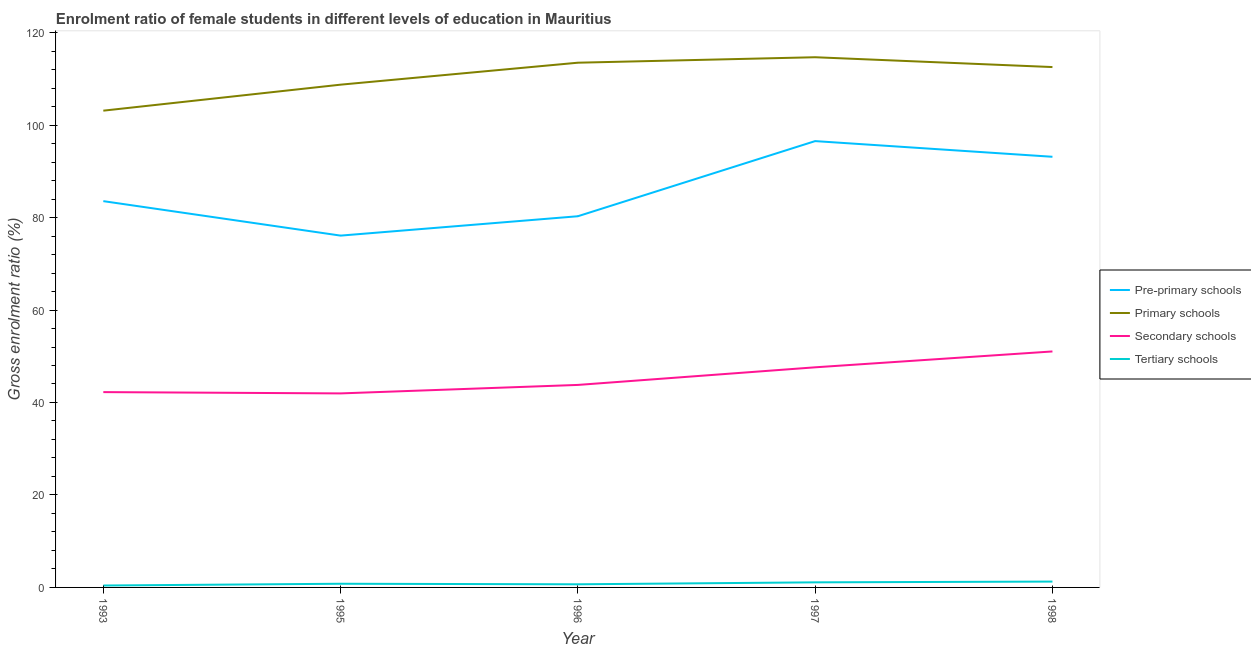How many different coloured lines are there?
Provide a short and direct response. 4. Does the line corresponding to gross enrolment ratio(male) in secondary schools intersect with the line corresponding to gross enrolment ratio(male) in pre-primary schools?
Your answer should be compact. No. Is the number of lines equal to the number of legend labels?
Provide a short and direct response. Yes. What is the gross enrolment ratio(male) in tertiary schools in 1998?
Your answer should be compact. 1.27. Across all years, what is the maximum gross enrolment ratio(male) in primary schools?
Keep it short and to the point. 114.68. Across all years, what is the minimum gross enrolment ratio(male) in pre-primary schools?
Make the answer very short. 76.1. In which year was the gross enrolment ratio(male) in primary schools minimum?
Provide a succinct answer. 1993. What is the total gross enrolment ratio(male) in secondary schools in the graph?
Your response must be concise. 226.66. What is the difference between the gross enrolment ratio(male) in primary schools in 1993 and that in 1995?
Give a very brief answer. -5.62. What is the difference between the gross enrolment ratio(male) in primary schools in 1998 and the gross enrolment ratio(male) in tertiary schools in 1996?
Offer a terse response. 111.87. What is the average gross enrolment ratio(male) in tertiary schools per year?
Keep it short and to the point. 0.85. In the year 1997, what is the difference between the gross enrolment ratio(male) in secondary schools and gross enrolment ratio(male) in primary schools?
Provide a short and direct response. -67.07. In how many years, is the gross enrolment ratio(male) in pre-primary schools greater than 72 %?
Keep it short and to the point. 5. What is the ratio of the gross enrolment ratio(male) in primary schools in 1997 to that in 1998?
Ensure brevity in your answer.  1.02. Is the difference between the gross enrolment ratio(male) in tertiary schools in 1996 and 1997 greater than the difference between the gross enrolment ratio(male) in pre-primary schools in 1996 and 1997?
Offer a terse response. Yes. What is the difference between the highest and the second highest gross enrolment ratio(male) in primary schools?
Keep it short and to the point. 1.18. What is the difference between the highest and the lowest gross enrolment ratio(male) in pre-primary schools?
Your answer should be compact. 20.44. In how many years, is the gross enrolment ratio(male) in primary schools greater than the average gross enrolment ratio(male) in primary schools taken over all years?
Your answer should be compact. 3. Is the sum of the gross enrolment ratio(male) in secondary schools in 1995 and 1996 greater than the maximum gross enrolment ratio(male) in tertiary schools across all years?
Your answer should be very brief. Yes. Is it the case that in every year, the sum of the gross enrolment ratio(male) in pre-primary schools and gross enrolment ratio(male) in primary schools is greater than the gross enrolment ratio(male) in secondary schools?
Your response must be concise. Yes. Does the gross enrolment ratio(male) in secondary schools monotonically increase over the years?
Your response must be concise. No. How many years are there in the graph?
Make the answer very short. 5. Does the graph contain any zero values?
Offer a terse response. No. Does the graph contain grids?
Give a very brief answer. No. Where does the legend appear in the graph?
Keep it short and to the point. Center right. How many legend labels are there?
Your answer should be very brief. 4. What is the title of the graph?
Your answer should be very brief. Enrolment ratio of female students in different levels of education in Mauritius. Does "Taxes on revenue" appear as one of the legend labels in the graph?
Give a very brief answer. No. What is the label or title of the Y-axis?
Keep it short and to the point. Gross enrolment ratio (%). What is the Gross enrolment ratio (%) in Pre-primary schools in 1993?
Your answer should be very brief. 83.55. What is the Gross enrolment ratio (%) in Primary schools in 1993?
Keep it short and to the point. 103.12. What is the Gross enrolment ratio (%) in Secondary schools in 1993?
Offer a terse response. 42.25. What is the Gross enrolment ratio (%) of Tertiary schools in 1993?
Provide a succinct answer. 0.41. What is the Gross enrolment ratio (%) of Pre-primary schools in 1995?
Your answer should be compact. 76.1. What is the Gross enrolment ratio (%) of Primary schools in 1995?
Keep it short and to the point. 108.74. What is the Gross enrolment ratio (%) of Secondary schools in 1995?
Your answer should be very brief. 41.97. What is the Gross enrolment ratio (%) of Tertiary schools in 1995?
Provide a short and direct response. 0.79. What is the Gross enrolment ratio (%) of Pre-primary schools in 1996?
Ensure brevity in your answer.  80.28. What is the Gross enrolment ratio (%) of Primary schools in 1996?
Your response must be concise. 113.49. What is the Gross enrolment ratio (%) of Secondary schools in 1996?
Offer a very short reply. 43.8. What is the Gross enrolment ratio (%) of Tertiary schools in 1996?
Make the answer very short. 0.68. What is the Gross enrolment ratio (%) in Pre-primary schools in 1997?
Offer a terse response. 96.54. What is the Gross enrolment ratio (%) of Primary schools in 1997?
Ensure brevity in your answer.  114.68. What is the Gross enrolment ratio (%) in Secondary schools in 1997?
Give a very brief answer. 47.61. What is the Gross enrolment ratio (%) of Tertiary schools in 1997?
Your response must be concise. 1.1. What is the Gross enrolment ratio (%) of Pre-primary schools in 1998?
Give a very brief answer. 93.15. What is the Gross enrolment ratio (%) in Primary schools in 1998?
Give a very brief answer. 112.55. What is the Gross enrolment ratio (%) of Secondary schools in 1998?
Provide a short and direct response. 51.04. What is the Gross enrolment ratio (%) of Tertiary schools in 1998?
Provide a short and direct response. 1.27. Across all years, what is the maximum Gross enrolment ratio (%) in Pre-primary schools?
Keep it short and to the point. 96.54. Across all years, what is the maximum Gross enrolment ratio (%) of Primary schools?
Offer a terse response. 114.68. Across all years, what is the maximum Gross enrolment ratio (%) in Secondary schools?
Provide a short and direct response. 51.04. Across all years, what is the maximum Gross enrolment ratio (%) of Tertiary schools?
Offer a terse response. 1.27. Across all years, what is the minimum Gross enrolment ratio (%) of Pre-primary schools?
Give a very brief answer. 76.1. Across all years, what is the minimum Gross enrolment ratio (%) of Primary schools?
Offer a terse response. 103.12. Across all years, what is the minimum Gross enrolment ratio (%) in Secondary schools?
Provide a succinct answer. 41.97. Across all years, what is the minimum Gross enrolment ratio (%) in Tertiary schools?
Give a very brief answer. 0.41. What is the total Gross enrolment ratio (%) in Pre-primary schools in the graph?
Offer a very short reply. 429.61. What is the total Gross enrolment ratio (%) of Primary schools in the graph?
Your answer should be compact. 552.58. What is the total Gross enrolment ratio (%) in Secondary schools in the graph?
Offer a terse response. 226.66. What is the total Gross enrolment ratio (%) in Tertiary schools in the graph?
Offer a very short reply. 4.25. What is the difference between the Gross enrolment ratio (%) of Pre-primary schools in 1993 and that in 1995?
Keep it short and to the point. 7.46. What is the difference between the Gross enrolment ratio (%) in Primary schools in 1993 and that in 1995?
Ensure brevity in your answer.  -5.62. What is the difference between the Gross enrolment ratio (%) of Secondary schools in 1993 and that in 1995?
Your answer should be compact. 0.28. What is the difference between the Gross enrolment ratio (%) of Tertiary schools in 1993 and that in 1995?
Give a very brief answer. -0.38. What is the difference between the Gross enrolment ratio (%) in Pre-primary schools in 1993 and that in 1996?
Offer a terse response. 3.27. What is the difference between the Gross enrolment ratio (%) in Primary schools in 1993 and that in 1996?
Make the answer very short. -10.37. What is the difference between the Gross enrolment ratio (%) of Secondary schools in 1993 and that in 1996?
Keep it short and to the point. -1.55. What is the difference between the Gross enrolment ratio (%) of Tertiary schools in 1993 and that in 1996?
Offer a very short reply. -0.26. What is the difference between the Gross enrolment ratio (%) of Pre-primary schools in 1993 and that in 1997?
Ensure brevity in your answer.  -12.99. What is the difference between the Gross enrolment ratio (%) in Primary schools in 1993 and that in 1997?
Give a very brief answer. -11.56. What is the difference between the Gross enrolment ratio (%) in Secondary schools in 1993 and that in 1997?
Ensure brevity in your answer.  -5.36. What is the difference between the Gross enrolment ratio (%) of Tertiary schools in 1993 and that in 1997?
Provide a short and direct response. -0.68. What is the difference between the Gross enrolment ratio (%) of Pre-primary schools in 1993 and that in 1998?
Offer a very short reply. -9.6. What is the difference between the Gross enrolment ratio (%) in Primary schools in 1993 and that in 1998?
Your response must be concise. -9.43. What is the difference between the Gross enrolment ratio (%) of Secondary schools in 1993 and that in 1998?
Ensure brevity in your answer.  -8.8. What is the difference between the Gross enrolment ratio (%) of Tertiary schools in 1993 and that in 1998?
Offer a very short reply. -0.85. What is the difference between the Gross enrolment ratio (%) in Pre-primary schools in 1995 and that in 1996?
Provide a succinct answer. -4.19. What is the difference between the Gross enrolment ratio (%) in Primary schools in 1995 and that in 1996?
Your answer should be compact. -4.75. What is the difference between the Gross enrolment ratio (%) in Secondary schools in 1995 and that in 1996?
Ensure brevity in your answer.  -1.83. What is the difference between the Gross enrolment ratio (%) of Tertiary schools in 1995 and that in 1996?
Provide a short and direct response. 0.12. What is the difference between the Gross enrolment ratio (%) of Pre-primary schools in 1995 and that in 1997?
Keep it short and to the point. -20.44. What is the difference between the Gross enrolment ratio (%) in Primary schools in 1995 and that in 1997?
Your answer should be compact. -5.93. What is the difference between the Gross enrolment ratio (%) of Secondary schools in 1995 and that in 1997?
Offer a terse response. -5.64. What is the difference between the Gross enrolment ratio (%) in Tertiary schools in 1995 and that in 1997?
Make the answer very short. -0.3. What is the difference between the Gross enrolment ratio (%) in Pre-primary schools in 1995 and that in 1998?
Your answer should be very brief. -17.05. What is the difference between the Gross enrolment ratio (%) of Primary schools in 1995 and that in 1998?
Make the answer very short. -3.81. What is the difference between the Gross enrolment ratio (%) in Secondary schools in 1995 and that in 1998?
Provide a succinct answer. -9.07. What is the difference between the Gross enrolment ratio (%) of Tertiary schools in 1995 and that in 1998?
Your response must be concise. -0.47. What is the difference between the Gross enrolment ratio (%) of Pre-primary schools in 1996 and that in 1997?
Ensure brevity in your answer.  -16.25. What is the difference between the Gross enrolment ratio (%) in Primary schools in 1996 and that in 1997?
Your answer should be very brief. -1.18. What is the difference between the Gross enrolment ratio (%) of Secondary schools in 1996 and that in 1997?
Provide a short and direct response. -3.81. What is the difference between the Gross enrolment ratio (%) in Tertiary schools in 1996 and that in 1997?
Provide a short and direct response. -0.42. What is the difference between the Gross enrolment ratio (%) of Pre-primary schools in 1996 and that in 1998?
Provide a succinct answer. -12.86. What is the difference between the Gross enrolment ratio (%) of Primary schools in 1996 and that in 1998?
Your answer should be very brief. 0.94. What is the difference between the Gross enrolment ratio (%) in Secondary schools in 1996 and that in 1998?
Offer a very short reply. -7.24. What is the difference between the Gross enrolment ratio (%) in Tertiary schools in 1996 and that in 1998?
Keep it short and to the point. -0.59. What is the difference between the Gross enrolment ratio (%) of Pre-primary schools in 1997 and that in 1998?
Keep it short and to the point. 3.39. What is the difference between the Gross enrolment ratio (%) of Primary schools in 1997 and that in 1998?
Ensure brevity in your answer.  2.13. What is the difference between the Gross enrolment ratio (%) in Secondary schools in 1997 and that in 1998?
Give a very brief answer. -3.43. What is the difference between the Gross enrolment ratio (%) of Tertiary schools in 1997 and that in 1998?
Provide a short and direct response. -0.17. What is the difference between the Gross enrolment ratio (%) of Pre-primary schools in 1993 and the Gross enrolment ratio (%) of Primary schools in 1995?
Keep it short and to the point. -25.19. What is the difference between the Gross enrolment ratio (%) of Pre-primary schools in 1993 and the Gross enrolment ratio (%) of Secondary schools in 1995?
Your answer should be very brief. 41.58. What is the difference between the Gross enrolment ratio (%) of Pre-primary schools in 1993 and the Gross enrolment ratio (%) of Tertiary schools in 1995?
Your response must be concise. 82.76. What is the difference between the Gross enrolment ratio (%) of Primary schools in 1993 and the Gross enrolment ratio (%) of Secondary schools in 1995?
Provide a succinct answer. 61.15. What is the difference between the Gross enrolment ratio (%) in Primary schools in 1993 and the Gross enrolment ratio (%) in Tertiary schools in 1995?
Keep it short and to the point. 102.33. What is the difference between the Gross enrolment ratio (%) in Secondary schools in 1993 and the Gross enrolment ratio (%) in Tertiary schools in 1995?
Ensure brevity in your answer.  41.45. What is the difference between the Gross enrolment ratio (%) in Pre-primary schools in 1993 and the Gross enrolment ratio (%) in Primary schools in 1996?
Your answer should be very brief. -29.94. What is the difference between the Gross enrolment ratio (%) in Pre-primary schools in 1993 and the Gross enrolment ratio (%) in Secondary schools in 1996?
Provide a short and direct response. 39.75. What is the difference between the Gross enrolment ratio (%) in Pre-primary schools in 1993 and the Gross enrolment ratio (%) in Tertiary schools in 1996?
Your response must be concise. 82.87. What is the difference between the Gross enrolment ratio (%) in Primary schools in 1993 and the Gross enrolment ratio (%) in Secondary schools in 1996?
Give a very brief answer. 59.32. What is the difference between the Gross enrolment ratio (%) in Primary schools in 1993 and the Gross enrolment ratio (%) in Tertiary schools in 1996?
Offer a very short reply. 102.44. What is the difference between the Gross enrolment ratio (%) in Secondary schools in 1993 and the Gross enrolment ratio (%) in Tertiary schools in 1996?
Your answer should be very brief. 41.57. What is the difference between the Gross enrolment ratio (%) in Pre-primary schools in 1993 and the Gross enrolment ratio (%) in Primary schools in 1997?
Ensure brevity in your answer.  -31.12. What is the difference between the Gross enrolment ratio (%) of Pre-primary schools in 1993 and the Gross enrolment ratio (%) of Secondary schools in 1997?
Your answer should be very brief. 35.94. What is the difference between the Gross enrolment ratio (%) in Pre-primary schools in 1993 and the Gross enrolment ratio (%) in Tertiary schools in 1997?
Offer a very short reply. 82.45. What is the difference between the Gross enrolment ratio (%) in Primary schools in 1993 and the Gross enrolment ratio (%) in Secondary schools in 1997?
Keep it short and to the point. 55.51. What is the difference between the Gross enrolment ratio (%) in Primary schools in 1993 and the Gross enrolment ratio (%) in Tertiary schools in 1997?
Your response must be concise. 102.02. What is the difference between the Gross enrolment ratio (%) in Secondary schools in 1993 and the Gross enrolment ratio (%) in Tertiary schools in 1997?
Your answer should be compact. 41.15. What is the difference between the Gross enrolment ratio (%) in Pre-primary schools in 1993 and the Gross enrolment ratio (%) in Primary schools in 1998?
Keep it short and to the point. -29. What is the difference between the Gross enrolment ratio (%) of Pre-primary schools in 1993 and the Gross enrolment ratio (%) of Secondary schools in 1998?
Ensure brevity in your answer.  32.51. What is the difference between the Gross enrolment ratio (%) of Pre-primary schools in 1993 and the Gross enrolment ratio (%) of Tertiary schools in 1998?
Your answer should be very brief. 82.29. What is the difference between the Gross enrolment ratio (%) of Primary schools in 1993 and the Gross enrolment ratio (%) of Secondary schools in 1998?
Give a very brief answer. 52.08. What is the difference between the Gross enrolment ratio (%) of Primary schools in 1993 and the Gross enrolment ratio (%) of Tertiary schools in 1998?
Provide a short and direct response. 101.86. What is the difference between the Gross enrolment ratio (%) of Secondary schools in 1993 and the Gross enrolment ratio (%) of Tertiary schools in 1998?
Provide a succinct answer. 40.98. What is the difference between the Gross enrolment ratio (%) in Pre-primary schools in 1995 and the Gross enrolment ratio (%) in Primary schools in 1996?
Keep it short and to the point. -37.4. What is the difference between the Gross enrolment ratio (%) of Pre-primary schools in 1995 and the Gross enrolment ratio (%) of Secondary schools in 1996?
Your answer should be compact. 32.3. What is the difference between the Gross enrolment ratio (%) in Pre-primary schools in 1995 and the Gross enrolment ratio (%) in Tertiary schools in 1996?
Your answer should be compact. 75.42. What is the difference between the Gross enrolment ratio (%) of Primary schools in 1995 and the Gross enrolment ratio (%) of Secondary schools in 1996?
Offer a terse response. 64.94. What is the difference between the Gross enrolment ratio (%) in Primary schools in 1995 and the Gross enrolment ratio (%) in Tertiary schools in 1996?
Provide a succinct answer. 108.07. What is the difference between the Gross enrolment ratio (%) in Secondary schools in 1995 and the Gross enrolment ratio (%) in Tertiary schools in 1996?
Offer a very short reply. 41.29. What is the difference between the Gross enrolment ratio (%) of Pre-primary schools in 1995 and the Gross enrolment ratio (%) of Primary schools in 1997?
Provide a succinct answer. -38.58. What is the difference between the Gross enrolment ratio (%) in Pre-primary schools in 1995 and the Gross enrolment ratio (%) in Secondary schools in 1997?
Offer a very short reply. 28.49. What is the difference between the Gross enrolment ratio (%) of Pre-primary schools in 1995 and the Gross enrolment ratio (%) of Tertiary schools in 1997?
Offer a terse response. 75. What is the difference between the Gross enrolment ratio (%) in Primary schools in 1995 and the Gross enrolment ratio (%) in Secondary schools in 1997?
Provide a succinct answer. 61.13. What is the difference between the Gross enrolment ratio (%) of Primary schools in 1995 and the Gross enrolment ratio (%) of Tertiary schools in 1997?
Provide a succinct answer. 107.64. What is the difference between the Gross enrolment ratio (%) in Secondary schools in 1995 and the Gross enrolment ratio (%) in Tertiary schools in 1997?
Provide a succinct answer. 40.87. What is the difference between the Gross enrolment ratio (%) of Pre-primary schools in 1995 and the Gross enrolment ratio (%) of Primary schools in 1998?
Your response must be concise. -36.45. What is the difference between the Gross enrolment ratio (%) of Pre-primary schools in 1995 and the Gross enrolment ratio (%) of Secondary schools in 1998?
Offer a terse response. 25.05. What is the difference between the Gross enrolment ratio (%) of Pre-primary schools in 1995 and the Gross enrolment ratio (%) of Tertiary schools in 1998?
Provide a short and direct response. 74.83. What is the difference between the Gross enrolment ratio (%) in Primary schools in 1995 and the Gross enrolment ratio (%) in Secondary schools in 1998?
Offer a terse response. 57.7. What is the difference between the Gross enrolment ratio (%) in Primary schools in 1995 and the Gross enrolment ratio (%) in Tertiary schools in 1998?
Offer a terse response. 107.48. What is the difference between the Gross enrolment ratio (%) in Secondary schools in 1995 and the Gross enrolment ratio (%) in Tertiary schools in 1998?
Your answer should be very brief. 40.7. What is the difference between the Gross enrolment ratio (%) in Pre-primary schools in 1996 and the Gross enrolment ratio (%) in Primary schools in 1997?
Your answer should be very brief. -34.39. What is the difference between the Gross enrolment ratio (%) in Pre-primary schools in 1996 and the Gross enrolment ratio (%) in Secondary schools in 1997?
Keep it short and to the point. 32.68. What is the difference between the Gross enrolment ratio (%) of Pre-primary schools in 1996 and the Gross enrolment ratio (%) of Tertiary schools in 1997?
Give a very brief answer. 79.19. What is the difference between the Gross enrolment ratio (%) of Primary schools in 1996 and the Gross enrolment ratio (%) of Secondary schools in 1997?
Keep it short and to the point. 65.89. What is the difference between the Gross enrolment ratio (%) of Primary schools in 1996 and the Gross enrolment ratio (%) of Tertiary schools in 1997?
Make the answer very short. 112.4. What is the difference between the Gross enrolment ratio (%) of Secondary schools in 1996 and the Gross enrolment ratio (%) of Tertiary schools in 1997?
Keep it short and to the point. 42.7. What is the difference between the Gross enrolment ratio (%) in Pre-primary schools in 1996 and the Gross enrolment ratio (%) in Primary schools in 1998?
Provide a short and direct response. -32.26. What is the difference between the Gross enrolment ratio (%) of Pre-primary schools in 1996 and the Gross enrolment ratio (%) of Secondary schools in 1998?
Offer a very short reply. 29.24. What is the difference between the Gross enrolment ratio (%) of Pre-primary schools in 1996 and the Gross enrolment ratio (%) of Tertiary schools in 1998?
Provide a succinct answer. 79.02. What is the difference between the Gross enrolment ratio (%) in Primary schools in 1996 and the Gross enrolment ratio (%) in Secondary schools in 1998?
Keep it short and to the point. 62.45. What is the difference between the Gross enrolment ratio (%) of Primary schools in 1996 and the Gross enrolment ratio (%) of Tertiary schools in 1998?
Keep it short and to the point. 112.23. What is the difference between the Gross enrolment ratio (%) of Secondary schools in 1996 and the Gross enrolment ratio (%) of Tertiary schools in 1998?
Provide a succinct answer. 42.53. What is the difference between the Gross enrolment ratio (%) of Pre-primary schools in 1997 and the Gross enrolment ratio (%) of Primary schools in 1998?
Your response must be concise. -16.01. What is the difference between the Gross enrolment ratio (%) of Pre-primary schools in 1997 and the Gross enrolment ratio (%) of Secondary schools in 1998?
Offer a terse response. 45.5. What is the difference between the Gross enrolment ratio (%) in Pre-primary schools in 1997 and the Gross enrolment ratio (%) in Tertiary schools in 1998?
Your answer should be very brief. 95.27. What is the difference between the Gross enrolment ratio (%) in Primary schools in 1997 and the Gross enrolment ratio (%) in Secondary schools in 1998?
Provide a short and direct response. 63.63. What is the difference between the Gross enrolment ratio (%) in Primary schools in 1997 and the Gross enrolment ratio (%) in Tertiary schools in 1998?
Give a very brief answer. 113.41. What is the difference between the Gross enrolment ratio (%) of Secondary schools in 1997 and the Gross enrolment ratio (%) of Tertiary schools in 1998?
Give a very brief answer. 46.34. What is the average Gross enrolment ratio (%) in Pre-primary schools per year?
Your answer should be very brief. 85.92. What is the average Gross enrolment ratio (%) in Primary schools per year?
Your answer should be compact. 110.52. What is the average Gross enrolment ratio (%) of Secondary schools per year?
Ensure brevity in your answer.  45.33. What is the average Gross enrolment ratio (%) of Tertiary schools per year?
Your response must be concise. 0.85. In the year 1993, what is the difference between the Gross enrolment ratio (%) in Pre-primary schools and Gross enrolment ratio (%) in Primary schools?
Make the answer very short. -19.57. In the year 1993, what is the difference between the Gross enrolment ratio (%) in Pre-primary schools and Gross enrolment ratio (%) in Secondary schools?
Provide a short and direct response. 41.3. In the year 1993, what is the difference between the Gross enrolment ratio (%) in Pre-primary schools and Gross enrolment ratio (%) in Tertiary schools?
Make the answer very short. 83.14. In the year 1993, what is the difference between the Gross enrolment ratio (%) of Primary schools and Gross enrolment ratio (%) of Secondary schools?
Give a very brief answer. 60.87. In the year 1993, what is the difference between the Gross enrolment ratio (%) of Primary schools and Gross enrolment ratio (%) of Tertiary schools?
Give a very brief answer. 102.71. In the year 1993, what is the difference between the Gross enrolment ratio (%) in Secondary schools and Gross enrolment ratio (%) in Tertiary schools?
Keep it short and to the point. 41.83. In the year 1995, what is the difference between the Gross enrolment ratio (%) of Pre-primary schools and Gross enrolment ratio (%) of Primary schools?
Keep it short and to the point. -32.65. In the year 1995, what is the difference between the Gross enrolment ratio (%) in Pre-primary schools and Gross enrolment ratio (%) in Secondary schools?
Provide a succinct answer. 34.13. In the year 1995, what is the difference between the Gross enrolment ratio (%) in Pre-primary schools and Gross enrolment ratio (%) in Tertiary schools?
Give a very brief answer. 75.3. In the year 1995, what is the difference between the Gross enrolment ratio (%) of Primary schools and Gross enrolment ratio (%) of Secondary schools?
Offer a very short reply. 66.78. In the year 1995, what is the difference between the Gross enrolment ratio (%) of Primary schools and Gross enrolment ratio (%) of Tertiary schools?
Offer a very short reply. 107.95. In the year 1995, what is the difference between the Gross enrolment ratio (%) in Secondary schools and Gross enrolment ratio (%) in Tertiary schools?
Your answer should be compact. 41.17. In the year 1996, what is the difference between the Gross enrolment ratio (%) of Pre-primary schools and Gross enrolment ratio (%) of Primary schools?
Offer a very short reply. -33.21. In the year 1996, what is the difference between the Gross enrolment ratio (%) of Pre-primary schools and Gross enrolment ratio (%) of Secondary schools?
Offer a very short reply. 36.49. In the year 1996, what is the difference between the Gross enrolment ratio (%) of Pre-primary schools and Gross enrolment ratio (%) of Tertiary schools?
Provide a short and direct response. 79.61. In the year 1996, what is the difference between the Gross enrolment ratio (%) of Primary schools and Gross enrolment ratio (%) of Secondary schools?
Give a very brief answer. 69.69. In the year 1996, what is the difference between the Gross enrolment ratio (%) in Primary schools and Gross enrolment ratio (%) in Tertiary schools?
Your answer should be compact. 112.82. In the year 1996, what is the difference between the Gross enrolment ratio (%) of Secondary schools and Gross enrolment ratio (%) of Tertiary schools?
Your answer should be compact. 43.12. In the year 1997, what is the difference between the Gross enrolment ratio (%) of Pre-primary schools and Gross enrolment ratio (%) of Primary schools?
Make the answer very short. -18.14. In the year 1997, what is the difference between the Gross enrolment ratio (%) of Pre-primary schools and Gross enrolment ratio (%) of Secondary schools?
Your answer should be compact. 48.93. In the year 1997, what is the difference between the Gross enrolment ratio (%) in Pre-primary schools and Gross enrolment ratio (%) in Tertiary schools?
Give a very brief answer. 95.44. In the year 1997, what is the difference between the Gross enrolment ratio (%) in Primary schools and Gross enrolment ratio (%) in Secondary schools?
Your answer should be very brief. 67.07. In the year 1997, what is the difference between the Gross enrolment ratio (%) of Primary schools and Gross enrolment ratio (%) of Tertiary schools?
Provide a short and direct response. 113.58. In the year 1997, what is the difference between the Gross enrolment ratio (%) in Secondary schools and Gross enrolment ratio (%) in Tertiary schools?
Offer a terse response. 46.51. In the year 1998, what is the difference between the Gross enrolment ratio (%) of Pre-primary schools and Gross enrolment ratio (%) of Primary schools?
Provide a succinct answer. -19.4. In the year 1998, what is the difference between the Gross enrolment ratio (%) in Pre-primary schools and Gross enrolment ratio (%) in Secondary schools?
Offer a terse response. 42.1. In the year 1998, what is the difference between the Gross enrolment ratio (%) of Pre-primary schools and Gross enrolment ratio (%) of Tertiary schools?
Make the answer very short. 91.88. In the year 1998, what is the difference between the Gross enrolment ratio (%) in Primary schools and Gross enrolment ratio (%) in Secondary schools?
Make the answer very short. 61.51. In the year 1998, what is the difference between the Gross enrolment ratio (%) in Primary schools and Gross enrolment ratio (%) in Tertiary schools?
Your answer should be very brief. 111.28. In the year 1998, what is the difference between the Gross enrolment ratio (%) in Secondary schools and Gross enrolment ratio (%) in Tertiary schools?
Keep it short and to the point. 49.78. What is the ratio of the Gross enrolment ratio (%) of Pre-primary schools in 1993 to that in 1995?
Provide a succinct answer. 1.1. What is the ratio of the Gross enrolment ratio (%) in Primary schools in 1993 to that in 1995?
Provide a succinct answer. 0.95. What is the ratio of the Gross enrolment ratio (%) in Secondary schools in 1993 to that in 1995?
Provide a short and direct response. 1.01. What is the ratio of the Gross enrolment ratio (%) of Tertiary schools in 1993 to that in 1995?
Make the answer very short. 0.52. What is the ratio of the Gross enrolment ratio (%) of Pre-primary schools in 1993 to that in 1996?
Offer a terse response. 1.04. What is the ratio of the Gross enrolment ratio (%) in Primary schools in 1993 to that in 1996?
Keep it short and to the point. 0.91. What is the ratio of the Gross enrolment ratio (%) in Secondary schools in 1993 to that in 1996?
Make the answer very short. 0.96. What is the ratio of the Gross enrolment ratio (%) in Tertiary schools in 1993 to that in 1996?
Your answer should be compact. 0.61. What is the ratio of the Gross enrolment ratio (%) of Pre-primary schools in 1993 to that in 1997?
Give a very brief answer. 0.87. What is the ratio of the Gross enrolment ratio (%) in Primary schools in 1993 to that in 1997?
Keep it short and to the point. 0.9. What is the ratio of the Gross enrolment ratio (%) of Secondary schools in 1993 to that in 1997?
Make the answer very short. 0.89. What is the ratio of the Gross enrolment ratio (%) in Tertiary schools in 1993 to that in 1997?
Your answer should be compact. 0.38. What is the ratio of the Gross enrolment ratio (%) of Pre-primary schools in 1993 to that in 1998?
Your answer should be compact. 0.9. What is the ratio of the Gross enrolment ratio (%) of Primary schools in 1993 to that in 1998?
Give a very brief answer. 0.92. What is the ratio of the Gross enrolment ratio (%) of Secondary schools in 1993 to that in 1998?
Offer a terse response. 0.83. What is the ratio of the Gross enrolment ratio (%) in Tertiary schools in 1993 to that in 1998?
Your response must be concise. 0.33. What is the ratio of the Gross enrolment ratio (%) in Pre-primary schools in 1995 to that in 1996?
Your answer should be compact. 0.95. What is the ratio of the Gross enrolment ratio (%) in Primary schools in 1995 to that in 1996?
Your answer should be very brief. 0.96. What is the ratio of the Gross enrolment ratio (%) of Secondary schools in 1995 to that in 1996?
Keep it short and to the point. 0.96. What is the ratio of the Gross enrolment ratio (%) in Tertiary schools in 1995 to that in 1996?
Make the answer very short. 1.17. What is the ratio of the Gross enrolment ratio (%) in Pre-primary schools in 1995 to that in 1997?
Your answer should be very brief. 0.79. What is the ratio of the Gross enrolment ratio (%) of Primary schools in 1995 to that in 1997?
Provide a succinct answer. 0.95. What is the ratio of the Gross enrolment ratio (%) of Secondary schools in 1995 to that in 1997?
Your response must be concise. 0.88. What is the ratio of the Gross enrolment ratio (%) of Tertiary schools in 1995 to that in 1997?
Your response must be concise. 0.72. What is the ratio of the Gross enrolment ratio (%) of Pre-primary schools in 1995 to that in 1998?
Offer a terse response. 0.82. What is the ratio of the Gross enrolment ratio (%) of Primary schools in 1995 to that in 1998?
Your answer should be compact. 0.97. What is the ratio of the Gross enrolment ratio (%) of Secondary schools in 1995 to that in 1998?
Offer a terse response. 0.82. What is the ratio of the Gross enrolment ratio (%) in Tertiary schools in 1995 to that in 1998?
Your answer should be compact. 0.63. What is the ratio of the Gross enrolment ratio (%) in Pre-primary schools in 1996 to that in 1997?
Ensure brevity in your answer.  0.83. What is the ratio of the Gross enrolment ratio (%) of Secondary schools in 1996 to that in 1997?
Ensure brevity in your answer.  0.92. What is the ratio of the Gross enrolment ratio (%) of Tertiary schools in 1996 to that in 1997?
Keep it short and to the point. 0.62. What is the ratio of the Gross enrolment ratio (%) of Pre-primary schools in 1996 to that in 1998?
Ensure brevity in your answer.  0.86. What is the ratio of the Gross enrolment ratio (%) of Primary schools in 1996 to that in 1998?
Your response must be concise. 1.01. What is the ratio of the Gross enrolment ratio (%) in Secondary schools in 1996 to that in 1998?
Make the answer very short. 0.86. What is the ratio of the Gross enrolment ratio (%) in Tertiary schools in 1996 to that in 1998?
Your response must be concise. 0.53. What is the ratio of the Gross enrolment ratio (%) of Pre-primary schools in 1997 to that in 1998?
Keep it short and to the point. 1.04. What is the ratio of the Gross enrolment ratio (%) of Primary schools in 1997 to that in 1998?
Provide a short and direct response. 1.02. What is the ratio of the Gross enrolment ratio (%) of Secondary schools in 1997 to that in 1998?
Make the answer very short. 0.93. What is the ratio of the Gross enrolment ratio (%) of Tertiary schools in 1997 to that in 1998?
Your response must be concise. 0.87. What is the difference between the highest and the second highest Gross enrolment ratio (%) of Pre-primary schools?
Give a very brief answer. 3.39. What is the difference between the highest and the second highest Gross enrolment ratio (%) in Primary schools?
Your answer should be compact. 1.18. What is the difference between the highest and the second highest Gross enrolment ratio (%) of Secondary schools?
Ensure brevity in your answer.  3.43. What is the difference between the highest and the second highest Gross enrolment ratio (%) in Tertiary schools?
Your answer should be compact. 0.17. What is the difference between the highest and the lowest Gross enrolment ratio (%) of Pre-primary schools?
Your answer should be compact. 20.44. What is the difference between the highest and the lowest Gross enrolment ratio (%) in Primary schools?
Make the answer very short. 11.56. What is the difference between the highest and the lowest Gross enrolment ratio (%) of Secondary schools?
Ensure brevity in your answer.  9.07. What is the difference between the highest and the lowest Gross enrolment ratio (%) in Tertiary schools?
Your response must be concise. 0.85. 